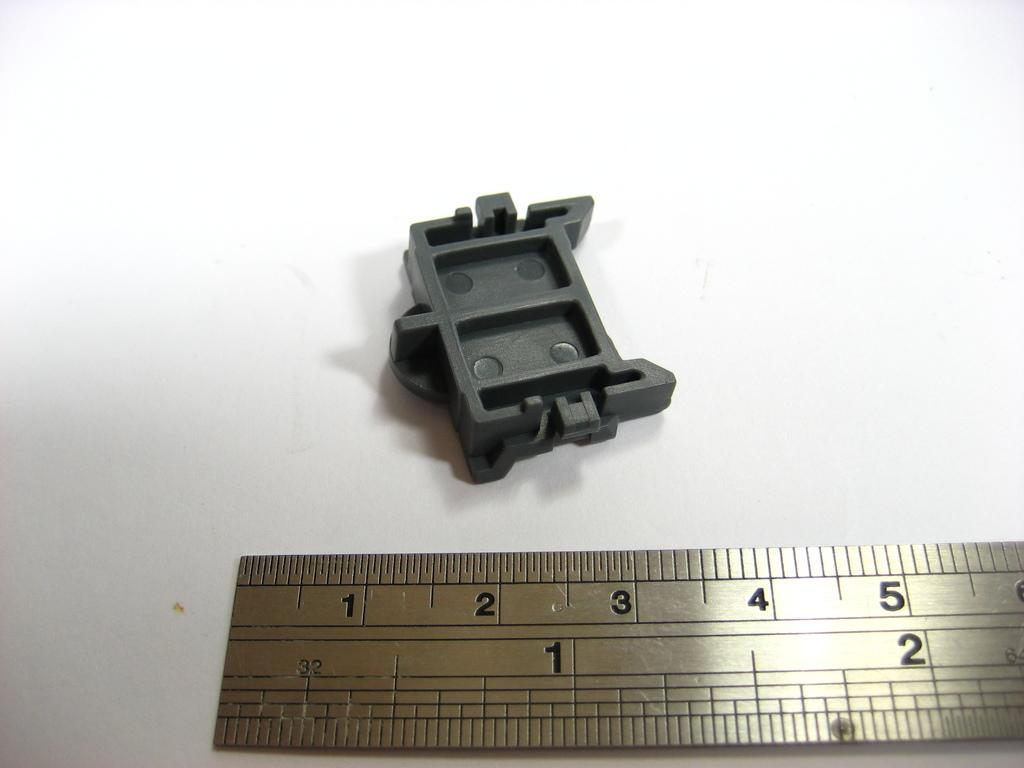<image>
Write a terse but informative summary of the picture. A plastic piece of something against a silver ruler showing 1 thru 5. 